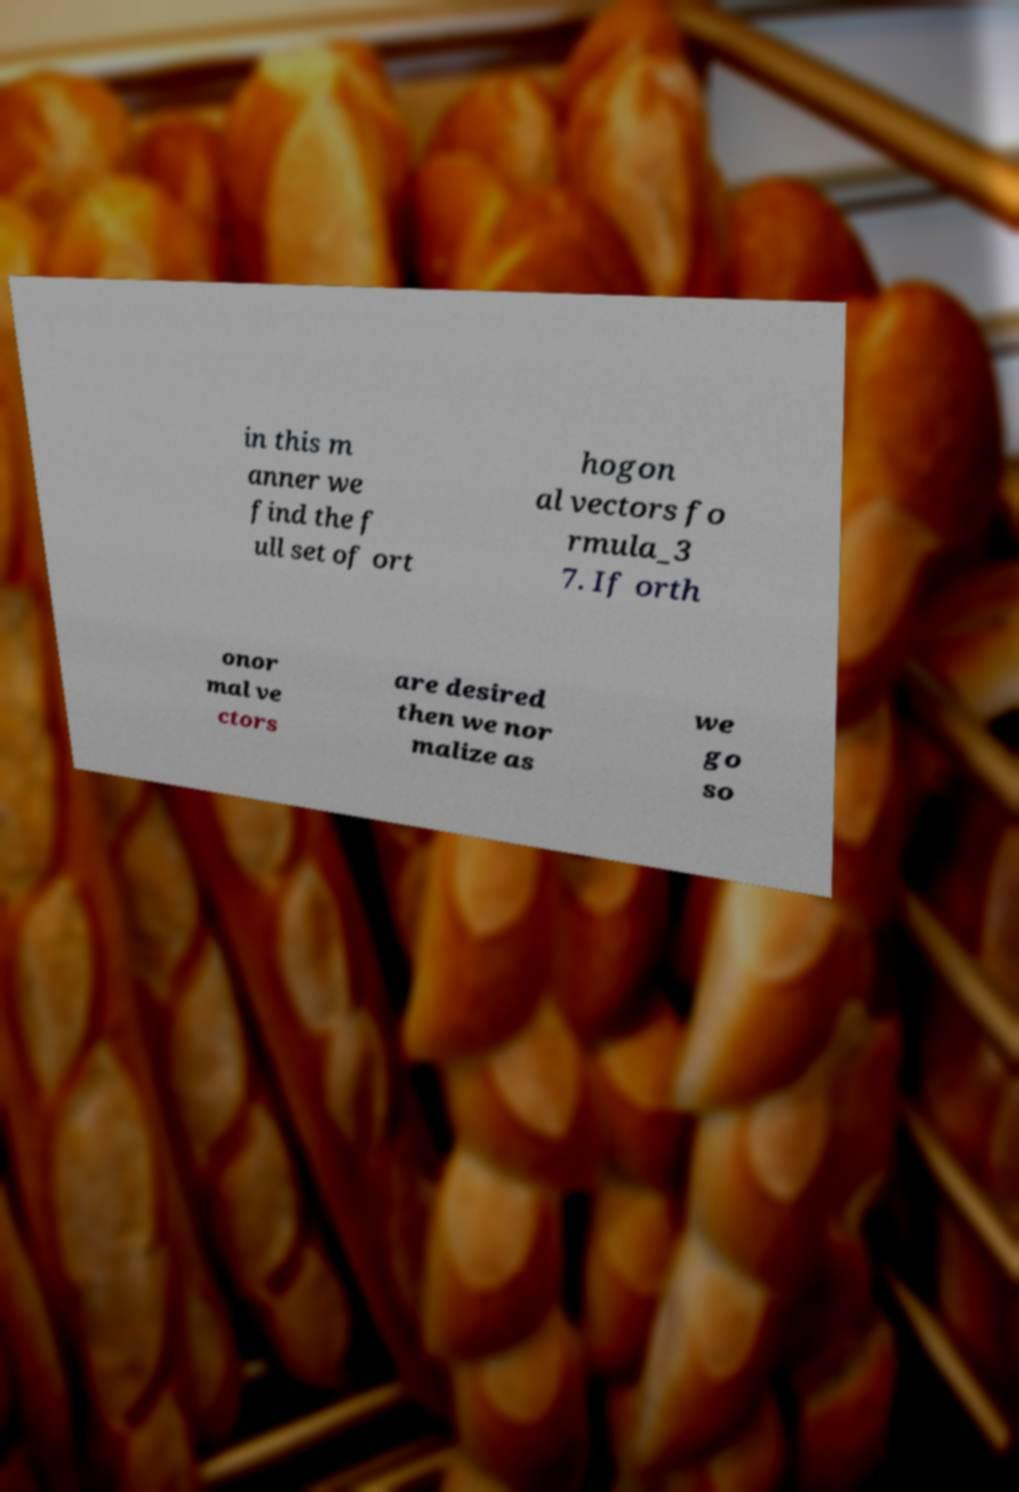Could you assist in decoding the text presented in this image and type it out clearly? in this m anner we find the f ull set of ort hogon al vectors fo rmula_3 7. If orth onor mal ve ctors are desired then we nor malize as we go so 